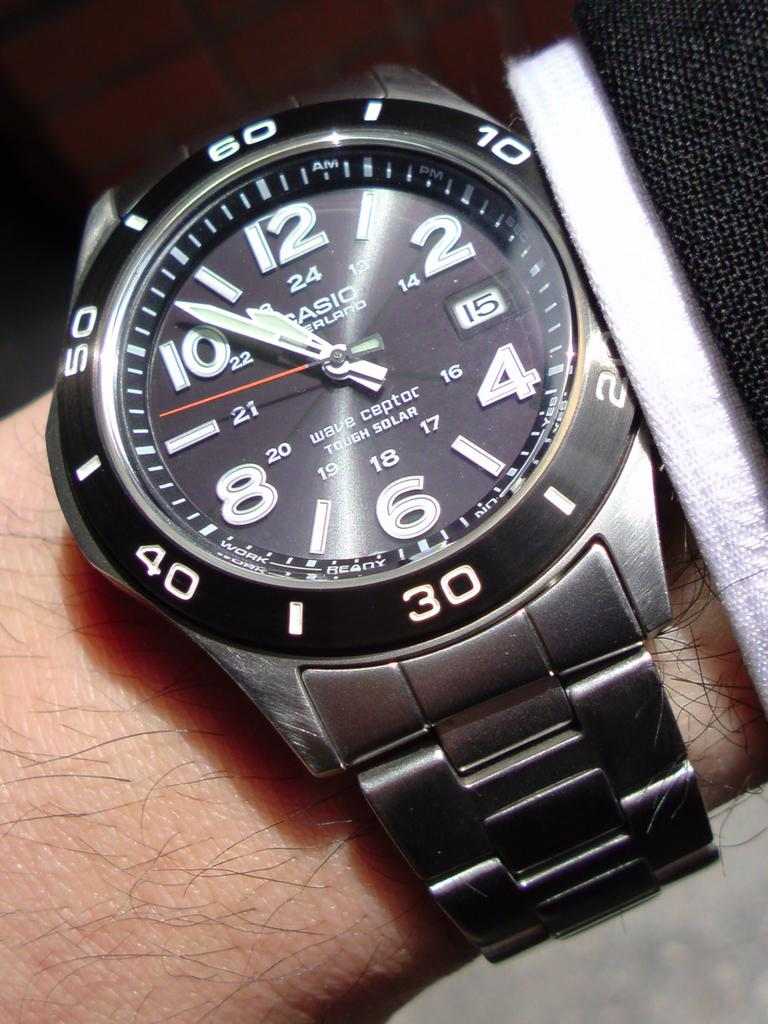<image>
Offer a succinct explanation of the picture presented. A person wearing a Casio wristwatch that indicates the time as 10:53. 